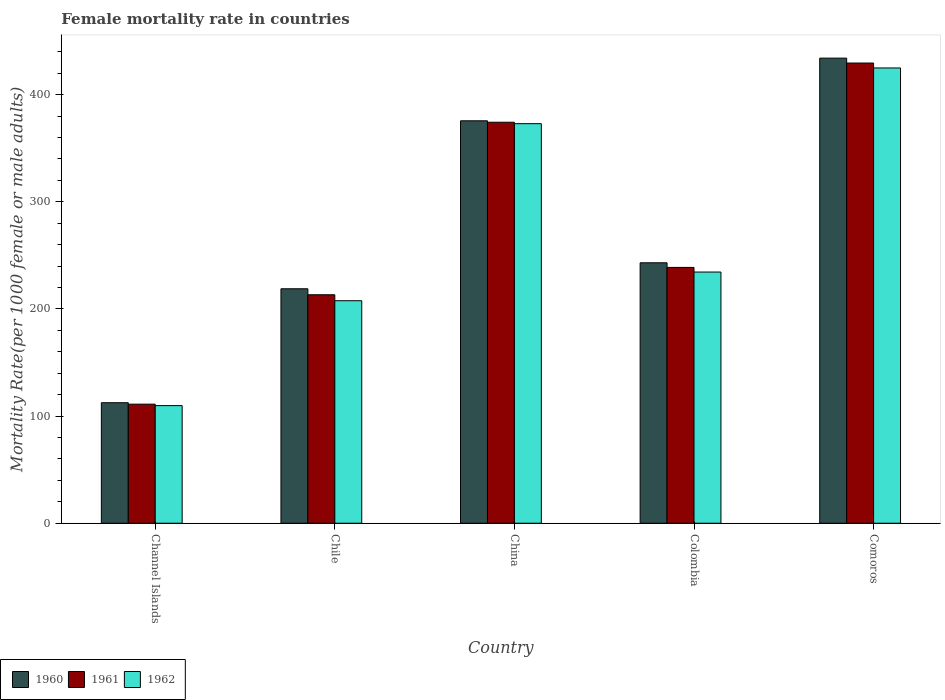Are the number of bars on each tick of the X-axis equal?
Give a very brief answer. Yes. How many bars are there on the 1st tick from the right?
Your response must be concise. 3. What is the label of the 4th group of bars from the left?
Give a very brief answer. Colombia. In how many cases, is the number of bars for a given country not equal to the number of legend labels?
Ensure brevity in your answer.  0. What is the female mortality rate in 1961 in China?
Give a very brief answer. 374.3. Across all countries, what is the maximum female mortality rate in 1960?
Your answer should be very brief. 434.15. Across all countries, what is the minimum female mortality rate in 1962?
Offer a very short reply. 109.79. In which country was the female mortality rate in 1960 maximum?
Offer a terse response. Comoros. In which country was the female mortality rate in 1960 minimum?
Your answer should be compact. Channel Islands. What is the total female mortality rate in 1961 in the graph?
Provide a succinct answer. 1367.06. What is the difference between the female mortality rate in 1961 in China and that in Colombia?
Your answer should be very brief. 135.51. What is the difference between the female mortality rate in 1962 in Chile and the female mortality rate in 1961 in Channel Islands?
Your response must be concise. 96.56. What is the average female mortality rate in 1961 per country?
Keep it short and to the point. 273.41. What is the difference between the female mortality rate of/in 1962 and female mortality rate of/in 1960 in Comoros?
Ensure brevity in your answer.  -9.18. What is the ratio of the female mortality rate in 1961 in Chile to that in China?
Keep it short and to the point. 0.57. Is the difference between the female mortality rate in 1962 in China and Colombia greater than the difference between the female mortality rate in 1960 in China and Colombia?
Give a very brief answer. Yes. What is the difference between the highest and the second highest female mortality rate in 1960?
Your answer should be very brief. 191.04. What is the difference between the highest and the lowest female mortality rate in 1961?
Your answer should be compact. 318.43. In how many countries, is the female mortality rate in 1960 greater than the average female mortality rate in 1960 taken over all countries?
Your answer should be very brief. 2. How many bars are there?
Provide a succinct answer. 15. Are all the bars in the graph horizontal?
Your response must be concise. No. What is the difference between two consecutive major ticks on the Y-axis?
Keep it short and to the point. 100. Does the graph contain grids?
Offer a terse response. No. What is the title of the graph?
Offer a very short reply. Female mortality rate in countries. Does "2000" appear as one of the legend labels in the graph?
Provide a short and direct response. No. What is the label or title of the X-axis?
Keep it short and to the point. Country. What is the label or title of the Y-axis?
Your response must be concise. Mortality Rate(per 1000 female or male adults). What is the Mortality Rate(per 1000 female or male adults) in 1960 in Channel Islands?
Ensure brevity in your answer.  112.48. What is the Mortality Rate(per 1000 female or male adults) in 1961 in Channel Islands?
Offer a terse response. 111.13. What is the Mortality Rate(per 1000 female or male adults) of 1962 in Channel Islands?
Keep it short and to the point. 109.79. What is the Mortality Rate(per 1000 female or male adults) in 1960 in Chile?
Provide a short and direct response. 218.85. What is the Mortality Rate(per 1000 female or male adults) in 1961 in Chile?
Ensure brevity in your answer.  213.27. What is the Mortality Rate(per 1000 female or male adults) in 1962 in Chile?
Ensure brevity in your answer.  207.69. What is the Mortality Rate(per 1000 female or male adults) of 1960 in China?
Provide a short and direct response. 375.65. What is the Mortality Rate(per 1000 female or male adults) in 1961 in China?
Your response must be concise. 374.3. What is the Mortality Rate(per 1000 female or male adults) in 1962 in China?
Offer a terse response. 372.96. What is the Mortality Rate(per 1000 female or male adults) in 1960 in Colombia?
Provide a succinct answer. 243.11. What is the Mortality Rate(per 1000 female or male adults) of 1961 in Colombia?
Offer a very short reply. 238.79. What is the Mortality Rate(per 1000 female or male adults) of 1962 in Colombia?
Offer a very short reply. 234.47. What is the Mortality Rate(per 1000 female or male adults) in 1960 in Comoros?
Make the answer very short. 434.15. What is the Mortality Rate(per 1000 female or male adults) in 1961 in Comoros?
Your answer should be compact. 429.56. What is the Mortality Rate(per 1000 female or male adults) in 1962 in Comoros?
Make the answer very short. 424.98. Across all countries, what is the maximum Mortality Rate(per 1000 female or male adults) in 1960?
Your answer should be compact. 434.15. Across all countries, what is the maximum Mortality Rate(per 1000 female or male adults) in 1961?
Provide a succinct answer. 429.56. Across all countries, what is the maximum Mortality Rate(per 1000 female or male adults) of 1962?
Keep it short and to the point. 424.98. Across all countries, what is the minimum Mortality Rate(per 1000 female or male adults) of 1960?
Make the answer very short. 112.48. Across all countries, what is the minimum Mortality Rate(per 1000 female or male adults) in 1961?
Provide a short and direct response. 111.13. Across all countries, what is the minimum Mortality Rate(per 1000 female or male adults) of 1962?
Offer a terse response. 109.79. What is the total Mortality Rate(per 1000 female or male adults) of 1960 in the graph?
Provide a short and direct response. 1384.24. What is the total Mortality Rate(per 1000 female or male adults) of 1961 in the graph?
Your response must be concise. 1367.06. What is the total Mortality Rate(per 1000 female or male adults) of 1962 in the graph?
Give a very brief answer. 1349.89. What is the difference between the Mortality Rate(per 1000 female or male adults) in 1960 in Channel Islands and that in Chile?
Offer a terse response. -106.37. What is the difference between the Mortality Rate(per 1000 female or male adults) of 1961 in Channel Islands and that in Chile?
Keep it short and to the point. -102.14. What is the difference between the Mortality Rate(per 1000 female or male adults) of 1962 in Channel Islands and that in Chile?
Provide a short and direct response. -97.9. What is the difference between the Mortality Rate(per 1000 female or male adults) in 1960 in Channel Islands and that in China?
Make the answer very short. -263.17. What is the difference between the Mortality Rate(per 1000 female or male adults) of 1961 in Channel Islands and that in China?
Your answer should be compact. -263.17. What is the difference between the Mortality Rate(per 1000 female or male adults) in 1962 in Channel Islands and that in China?
Make the answer very short. -263.17. What is the difference between the Mortality Rate(per 1000 female or male adults) in 1960 in Channel Islands and that in Colombia?
Your answer should be very brief. -130.63. What is the difference between the Mortality Rate(per 1000 female or male adults) of 1961 in Channel Islands and that in Colombia?
Give a very brief answer. -127.66. What is the difference between the Mortality Rate(per 1000 female or male adults) in 1962 in Channel Islands and that in Colombia?
Your answer should be compact. -124.69. What is the difference between the Mortality Rate(per 1000 female or male adults) of 1960 in Channel Islands and that in Comoros?
Give a very brief answer. -321.67. What is the difference between the Mortality Rate(per 1000 female or male adults) in 1961 in Channel Islands and that in Comoros?
Make the answer very short. -318.43. What is the difference between the Mortality Rate(per 1000 female or male adults) in 1962 in Channel Islands and that in Comoros?
Provide a succinct answer. -315.19. What is the difference between the Mortality Rate(per 1000 female or male adults) in 1960 in Chile and that in China?
Ensure brevity in your answer.  -156.8. What is the difference between the Mortality Rate(per 1000 female or male adults) in 1961 in Chile and that in China?
Offer a very short reply. -161.03. What is the difference between the Mortality Rate(per 1000 female or male adults) in 1962 in Chile and that in China?
Provide a short and direct response. -165.27. What is the difference between the Mortality Rate(per 1000 female or male adults) in 1960 in Chile and that in Colombia?
Your answer should be compact. -24.26. What is the difference between the Mortality Rate(per 1000 female or male adults) of 1961 in Chile and that in Colombia?
Ensure brevity in your answer.  -25.52. What is the difference between the Mortality Rate(per 1000 female or male adults) in 1962 in Chile and that in Colombia?
Offer a very short reply. -26.79. What is the difference between the Mortality Rate(per 1000 female or male adults) in 1960 in Chile and that in Comoros?
Give a very brief answer. -215.3. What is the difference between the Mortality Rate(per 1000 female or male adults) of 1961 in Chile and that in Comoros?
Your response must be concise. -216.29. What is the difference between the Mortality Rate(per 1000 female or male adults) in 1962 in Chile and that in Comoros?
Your answer should be very brief. -217.29. What is the difference between the Mortality Rate(per 1000 female or male adults) of 1960 in China and that in Colombia?
Offer a very short reply. 132.54. What is the difference between the Mortality Rate(per 1000 female or male adults) in 1961 in China and that in Colombia?
Make the answer very short. 135.51. What is the difference between the Mortality Rate(per 1000 female or male adults) of 1962 in China and that in Colombia?
Your answer should be compact. 138.48. What is the difference between the Mortality Rate(per 1000 female or male adults) of 1960 in China and that in Comoros?
Provide a succinct answer. -58.5. What is the difference between the Mortality Rate(per 1000 female or male adults) of 1961 in China and that in Comoros?
Ensure brevity in your answer.  -55.26. What is the difference between the Mortality Rate(per 1000 female or male adults) in 1962 in China and that in Comoros?
Provide a short and direct response. -52.02. What is the difference between the Mortality Rate(per 1000 female or male adults) of 1960 in Colombia and that in Comoros?
Your response must be concise. -191.04. What is the difference between the Mortality Rate(per 1000 female or male adults) in 1961 in Colombia and that in Comoros?
Provide a succinct answer. -190.77. What is the difference between the Mortality Rate(per 1000 female or male adults) of 1962 in Colombia and that in Comoros?
Ensure brevity in your answer.  -190.5. What is the difference between the Mortality Rate(per 1000 female or male adults) in 1960 in Channel Islands and the Mortality Rate(per 1000 female or male adults) in 1961 in Chile?
Ensure brevity in your answer.  -100.79. What is the difference between the Mortality Rate(per 1000 female or male adults) in 1960 in Channel Islands and the Mortality Rate(per 1000 female or male adults) in 1962 in Chile?
Give a very brief answer. -95.21. What is the difference between the Mortality Rate(per 1000 female or male adults) in 1961 in Channel Islands and the Mortality Rate(per 1000 female or male adults) in 1962 in Chile?
Provide a succinct answer. -96.56. What is the difference between the Mortality Rate(per 1000 female or male adults) of 1960 in Channel Islands and the Mortality Rate(per 1000 female or male adults) of 1961 in China?
Offer a very short reply. -261.82. What is the difference between the Mortality Rate(per 1000 female or male adults) of 1960 in Channel Islands and the Mortality Rate(per 1000 female or male adults) of 1962 in China?
Provide a short and direct response. -260.48. What is the difference between the Mortality Rate(per 1000 female or male adults) in 1961 in Channel Islands and the Mortality Rate(per 1000 female or male adults) in 1962 in China?
Keep it short and to the point. -261.82. What is the difference between the Mortality Rate(per 1000 female or male adults) in 1960 in Channel Islands and the Mortality Rate(per 1000 female or male adults) in 1961 in Colombia?
Provide a short and direct response. -126.31. What is the difference between the Mortality Rate(per 1000 female or male adults) in 1960 in Channel Islands and the Mortality Rate(per 1000 female or male adults) in 1962 in Colombia?
Provide a short and direct response. -121.99. What is the difference between the Mortality Rate(per 1000 female or male adults) of 1961 in Channel Islands and the Mortality Rate(per 1000 female or male adults) of 1962 in Colombia?
Offer a very short reply. -123.34. What is the difference between the Mortality Rate(per 1000 female or male adults) of 1960 in Channel Islands and the Mortality Rate(per 1000 female or male adults) of 1961 in Comoros?
Give a very brief answer. -317.08. What is the difference between the Mortality Rate(per 1000 female or male adults) of 1960 in Channel Islands and the Mortality Rate(per 1000 female or male adults) of 1962 in Comoros?
Provide a short and direct response. -312.5. What is the difference between the Mortality Rate(per 1000 female or male adults) of 1961 in Channel Islands and the Mortality Rate(per 1000 female or male adults) of 1962 in Comoros?
Your answer should be compact. -313.84. What is the difference between the Mortality Rate(per 1000 female or male adults) of 1960 in Chile and the Mortality Rate(per 1000 female or male adults) of 1961 in China?
Ensure brevity in your answer.  -155.45. What is the difference between the Mortality Rate(per 1000 female or male adults) of 1960 in Chile and the Mortality Rate(per 1000 female or male adults) of 1962 in China?
Your answer should be compact. -154.11. What is the difference between the Mortality Rate(per 1000 female or male adults) of 1961 in Chile and the Mortality Rate(per 1000 female or male adults) of 1962 in China?
Keep it short and to the point. -159.69. What is the difference between the Mortality Rate(per 1000 female or male adults) of 1960 in Chile and the Mortality Rate(per 1000 female or male adults) of 1961 in Colombia?
Make the answer very short. -19.94. What is the difference between the Mortality Rate(per 1000 female or male adults) in 1960 in Chile and the Mortality Rate(per 1000 female or male adults) in 1962 in Colombia?
Your response must be concise. -15.62. What is the difference between the Mortality Rate(per 1000 female or male adults) of 1961 in Chile and the Mortality Rate(per 1000 female or male adults) of 1962 in Colombia?
Offer a very short reply. -21.2. What is the difference between the Mortality Rate(per 1000 female or male adults) in 1960 in Chile and the Mortality Rate(per 1000 female or male adults) in 1961 in Comoros?
Your response must be concise. -210.72. What is the difference between the Mortality Rate(per 1000 female or male adults) of 1960 in Chile and the Mortality Rate(per 1000 female or male adults) of 1962 in Comoros?
Keep it short and to the point. -206.13. What is the difference between the Mortality Rate(per 1000 female or male adults) of 1961 in Chile and the Mortality Rate(per 1000 female or male adults) of 1962 in Comoros?
Your response must be concise. -211.71. What is the difference between the Mortality Rate(per 1000 female or male adults) in 1960 in China and the Mortality Rate(per 1000 female or male adults) in 1961 in Colombia?
Ensure brevity in your answer.  136.86. What is the difference between the Mortality Rate(per 1000 female or male adults) in 1960 in China and the Mortality Rate(per 1000 female or male adults) in 1962 in Colombia?
Your answer should be very brief. 141.17. What is the difference between the Mortality Rate(per 1000 female or male adults) in 1961 in China and the Mortality Rate(per 1000 female or male adults) in 1962 in Colombia?
Keep it short and to the point. 139.83. What is the difference between the Mortality Rate(per 1000 female or male adults) in 1960 in China and the Mortality Rate(per 1000 female or male adults) in 1961 in Comoros?
Offer a very short reply. -53.92. What is the difference between the Mortality Rate(per 1000 female or male adults) in 1960 in China and the Mortality Rate(per 1000 female or male adults) in 1962 in Comoros?
Make the answer very short. -49.33. What is the difference between the Mortality Rate(per 1000 female or male adults) in 1961 in China and the Mortality Rate(per 1000 female or male adults) in 1962 in Comoros?
Your response must be concise. -50.67. What is the difference between the Mortality Rate(per 1000 female or male adults) of 1960 in Colombia and the Mortality Rate(per 1000 female or male adults) of 1961 in Comoros?
Keep it short and to the point. -186.46. What is the difference between the Mortality Rate(per 1000 female or male adults) in 1960 in Colombia and the Mortality Rate(per 1000 female or male adults) in 1962 in Comoros?
Make the answer very short. -181.87. What is the difference between the Mortality Rate(per 1000 female or male adults) in 1961 in Colombia and the Mortality Rate(per 1000 female or male adults) in 1962 in Comoros?
Keep it short and to the point. -186.19. What is the average Mortality Rate(per 1000 female or male adults) of 1960 per country?
Your answer should be compact. 276.85. What is the average Mortality Rate(per 1000 female or male adults) in 1961 per country?
Your answer should be very brief. 273.41. What is the average Mortality Rate(per 1000 female or male adults) of 1962 per country?
Make the answer very short. 269.98. What is the difference between the Mortality Rate(per 1000 female or male adults) of 1960 and Mortality Rate(per 1000 female or male adults) of 1961 in Channel Islands?
Provide a succinct answer. 1.35. What is the difference between the Mortality Rate(per 1000 female or male adults) of 1960 and Mortality Rate(per 1000 female or male adults) of 1962 in Channel Islands?
Give a very brief answer. 2.7. What is the difference between the Mortality Rate(per 1000 female or male adults) in 1961 and Mortality Rate(per 1000 female or male adults) in 1962 in Channel Islands?
Give a very brief answer. 1.35. What is the difference between the Mortality Rate(per 1000 female or male adults) in 1960 and Mortality Rate(per 1000 female or male adults) in 1961 in Chile?
Give a very brief answer. 5.58. What is the difference between the Mortality Rate(per 1000 female or male adults) in 1960 and Mortality Rate(per 1000 female or male adults) in 1962 in Chile?
Offer a terse response. 11.16. What is the difference between the Mortality Rate(per 1000 female or male adults) of 1961 and Mortality Rate(per 1000 female or male adults) of 1962 in Chile?
Offer a very short reply. 5.58. What is the difference between the Mortality Rate(per 1000 female or male adults) of 1960 and Mortality Rate(per 1000 female or male adults) of 1961 in China?
Provide a succinct answer. 1.34. What is the difference between the Mortality Rate(per 1000 female or male adults) in 1960 and Mortality Rate(per 1000 female or male adults) in 1962 in China?
Offer a very short reply. 2.69. What is the difference between the Mortality Rate(per 1000 female or male adults) in 1961 and Mortality Rate(per 1000 female or male adults) in 1962 in China?
Offer a terse response. 1.34. What is the difference between the Mortality Rate(per 1000 female or male adults) in 1960 and Mortality Rate(per 1000 female or male adults) in 1961 in Colombia?
Give a very brief answer. 4.32. What is the difference between the Mortality Rate(per 1000 female or male adults) of 1960 and Mortality Rate(per 1000 female or male adults) of 1962 in Colombia?
Offer a terse response. 8.63. What is the difference between the Mortality Rate(per 1000 female or male adults) in 1961 and Mortality Rate(per 1000 female or male adults) in 1962 in Colombia?
Your answer should be very brief. 4.32. What is the difference between the Mortality Rate(per 1000 female or male adults) in 1960 and Mortality Rate(per 1000 female or male adults) in 1961 in Comoros?
Provide a succinct answer. 4.59. What is the difference between the Mortality Rate(per 1000 female or male adults) of 1960 and Mortality Rate(per 1000 female or male adults) of 1962 in Comoros?
Ensure brevity in your answer.  9.18. What is the difference between the Mortality Rate(per 1000 female or male adults) in 1961 and Mortality Rate(per 1000 female or male adults) in 1962 in Comoros?
Your response must be concise. 4.59. What is the ratio of the Mortality Rate(per 1000 female or male adults) in 1960 in Channel Islands to that in Chile?
Provide a short and direct response. 0.51. What is the ratio of the Mortality Rate(per 1000 female or male adults) of 1961 in Channel Islands to that in Chile?
Your response must be concise. 0.52. What is the ratio of the Mortality Rate(per 1000 female or male adults) of 1962 in Channel Islands to that in Chile?
Your answer should be very brief. 0.53. What is the ratio of the Mortality Rate(per 1000 female or male adults) in 1960 in Channel Islands to that in China?
Offer a very short reply. 0.3. What is the ratio of the Mortality Rate(per 1000 female or male adults) in 1961 in Channel Islands to that in China?
Make the answer very short. 0.3. What is the ratio of the Mortality Rate(per 1000 female or male adults) in 1962 in Channel Islands to that in China?
Provide a succinct answer. 0.29. What is the ratio of the Mortality Rate(per 1000 female or male adults) in 1960 in Channel Islands to that in Colombia?
Provide a short and direct response. 0.46. What is the ratio of the Mortality Rate(per 1000 female or male adults) in 1961 in Channel Islands to that in Colombia?
Provide a succinct answer. 0.47. What is the ratio of the Mortality Rate(per 1000 female or male adults) of 1962 in Channel Islands to that in Colombia?
Your answer should be very brief. 0.47. What is the ratio of the Mortality Rate(per 1000 female or male adults) of 1960 in Channel Islands to that in Comoros?
Ensure brevity in your answer.  0.26. What is the ratio of the Mortality Rate(per 1000 female or male adults) of 1961 in Channel Islands to that in Comoros?
Give a very brief answer. 0.26. What is the ratio of the Mortality Rate(per 1000 female or male adults) of 1962 in Channel Islands to that in Comoros?
Provide a short and direct response. 0.26. What is the ratio of the Mortality Rate(per 1000 female or male adults) of 1960 in Chile to that in China?
Offer a terse response. 0.58. What is the ratio of the Mortality Rate(per 1000 female or male adults) of 1961 in Chile to that in China?
Keep it short and to the point. 0.57. What is the ratio of the Mortality Rate(per 1000 female or male adults) in 1962 in Chile to that in China?
Offer a terse response. 0.56. What is the ratio of the Mortality Rate(per 1000 female or male adults) of 1960 in Chile to that in Colombia?
Your answer should be very brief. 0.9. What is the ratio of the Mortality Rate(per 1000 female or male adults) in 1961 in Chile to that in Colombia?
Your answer should be compact. 0.89. What is the ratio of the Mortality Rate(per 1000 female or male adults) in 1962 in Chile to that in Colombia?
Offer a very short reply. 0.89. What is the ratio of the Mortality Rate(per 1000 female or male adults) of 1960 in Chile to that in Comoros?
Make the answer very short. 0.5. What is the ratio of the Mortality Rate(per 1000 female or male adults) in 1961 in Chile to that in Comoros?
Make the answer very short. 0.5. What is the ratio of the Mortality Rate(per 1000 female or male adults) in 1962 in Chile to that in Comoros?
Provide a succinct answer. 0.49. What is the ratio of the Mortality Rate(per 1000 female or male adults) in 1960 in China to that in Colombia?
Make the answer very short. 1.55. What is the ratio of the Mortality Rate(per 1000 female or male adults) of 1961 in China to that in Colombia?
Provide a succinct answer. 1.57. What is the ratio of the Mortality Rate(per 1000 female or male adults) of 1962 in China to that in Colombia?
Your answer should be very brief. 1.59. What is the ratio of the Mortality Rate(per 1000 female or male adults) of 1960 in China to that in Comoros?
Your response must be concise. 0.87. What is the ratio of the Mortality Rate(per 1000 female or male adults) in 1961 in China to that in Comoros?
Offer a terse response. 0.87. What is the ratio of the Mortality Rate(per 1000 female or male adults) in 1962 in China to that in Comoros?
Offer a terse response. 0.88. What is the ratio of the Mortality Rate(per 1000 female or male adults) of 1960 in Colombia to that in Comoros?
Give a very brief answer. 0.56. What is the ratio of the Mortality Rate(per 1000 female or male adults) in 1961 in Colombia to that in Comoros?
Provide a succinct answer. 0.56. What is the ratio of the Mortality Rate(per 1000 female or male adults) in 1962 in Colombia to that in Comoros?
Keep it short and to the point. 0.55. What is the difference between the highest and the second highest Mortality Rate(per 1000 female or male adults) of 1960?
Ensure brevity in your answer.  58.5. What is the difference between the highest and the second highest Mortality Rate(per 1000 female or male adults) of 1961?
Provide a short and direct response. 55.26. What is the difference between the highest and the second highest Mortality Rate(per 1000 female or male adults) in 1962?
Keep it short and to the point. 52.02. What is the difference between the highest and the lowest Mortality Rate(per 1000 female or male adults) in 1960?
Your answer should be compact. 321.67. What is the difference between the highest and the lowest Mortality Rate(per 1000 female or male adults) in 1961?
Provide a short and direct response. 318.43. What is the difference between the highest and the lowest Mortality Rate(per 1000 female or male adults) in 1962?
Your response must be concise. 315.19. 